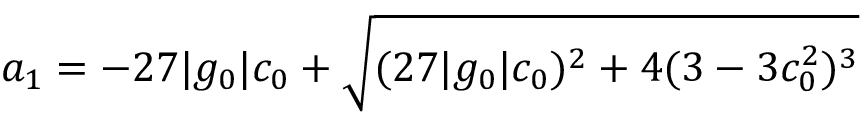Convert formula to latex. <formula><loc_0><loc_0><loc_500><loc_500>a _ { 1 } = - 2 7 | g _ { 0 } | c _ { 0 } + \sqrt { ( 2 7 | g _ { 0 } | c _ { 0 } ) ^ { 2 } + 4 ( 3 - 3 c _ { 0 } ^ { 2 } ) ^ { 3 } }</formula> 